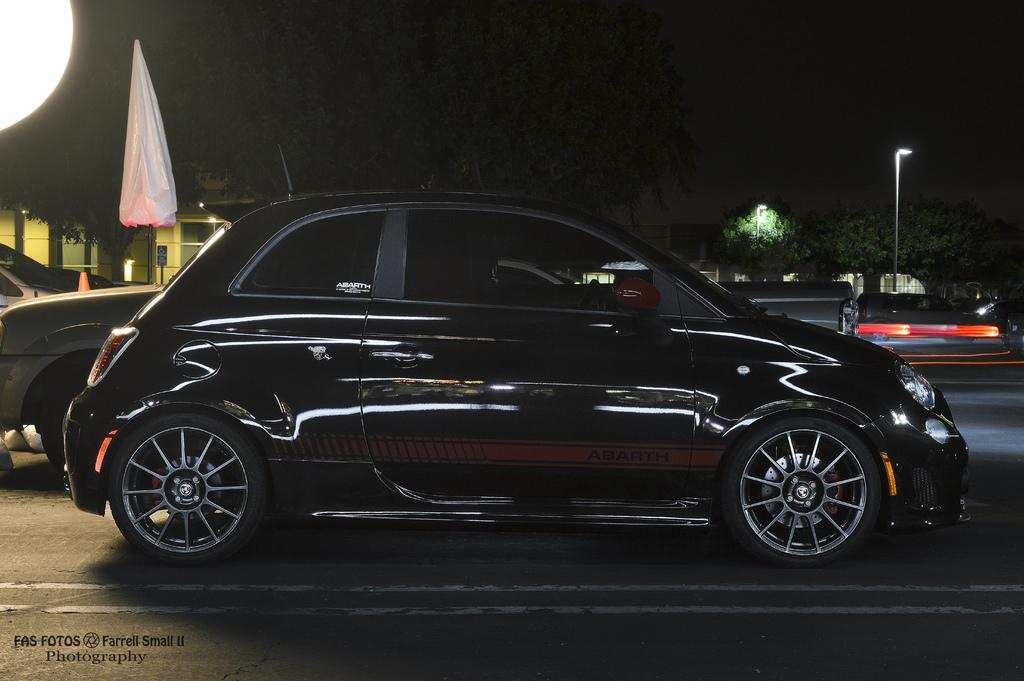What is the main feature of the image? There is a road in the image. What is happening on the road? There are cars on the road. What can be seen in the background of the image? There are trees and light poles in the background of the image. Can you see a horse rubbing against the light poles in the image? No, there is no horse present in the image, and therefore no such activity can be observed. 